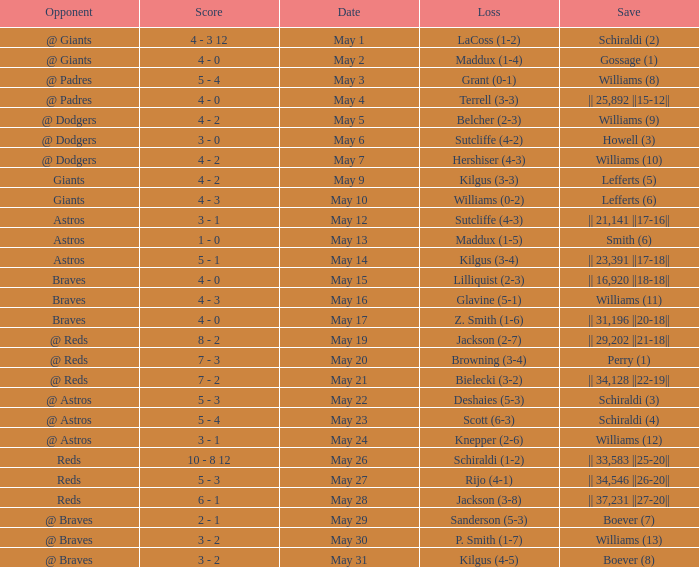Name the opponent for save of williams (9) @ Dodgers. 